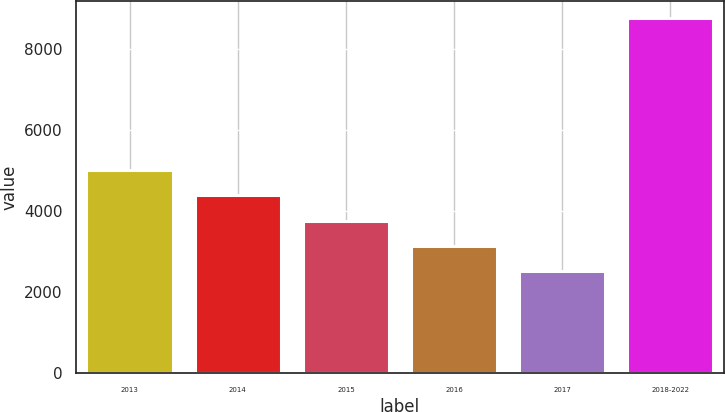<chart> <loc_0><loc_0><loc_500><loc_500><bar_chart><fcel>2013<fcel>2014<fcel>2015<fcel>2016<fcel>2017<fcel>2018-2022<nl><fcel>5016.4<fcel>4392.8<fcel>3769.2<fcel>3145.6<fcel>2522<fcel>8758<nl></chart> 